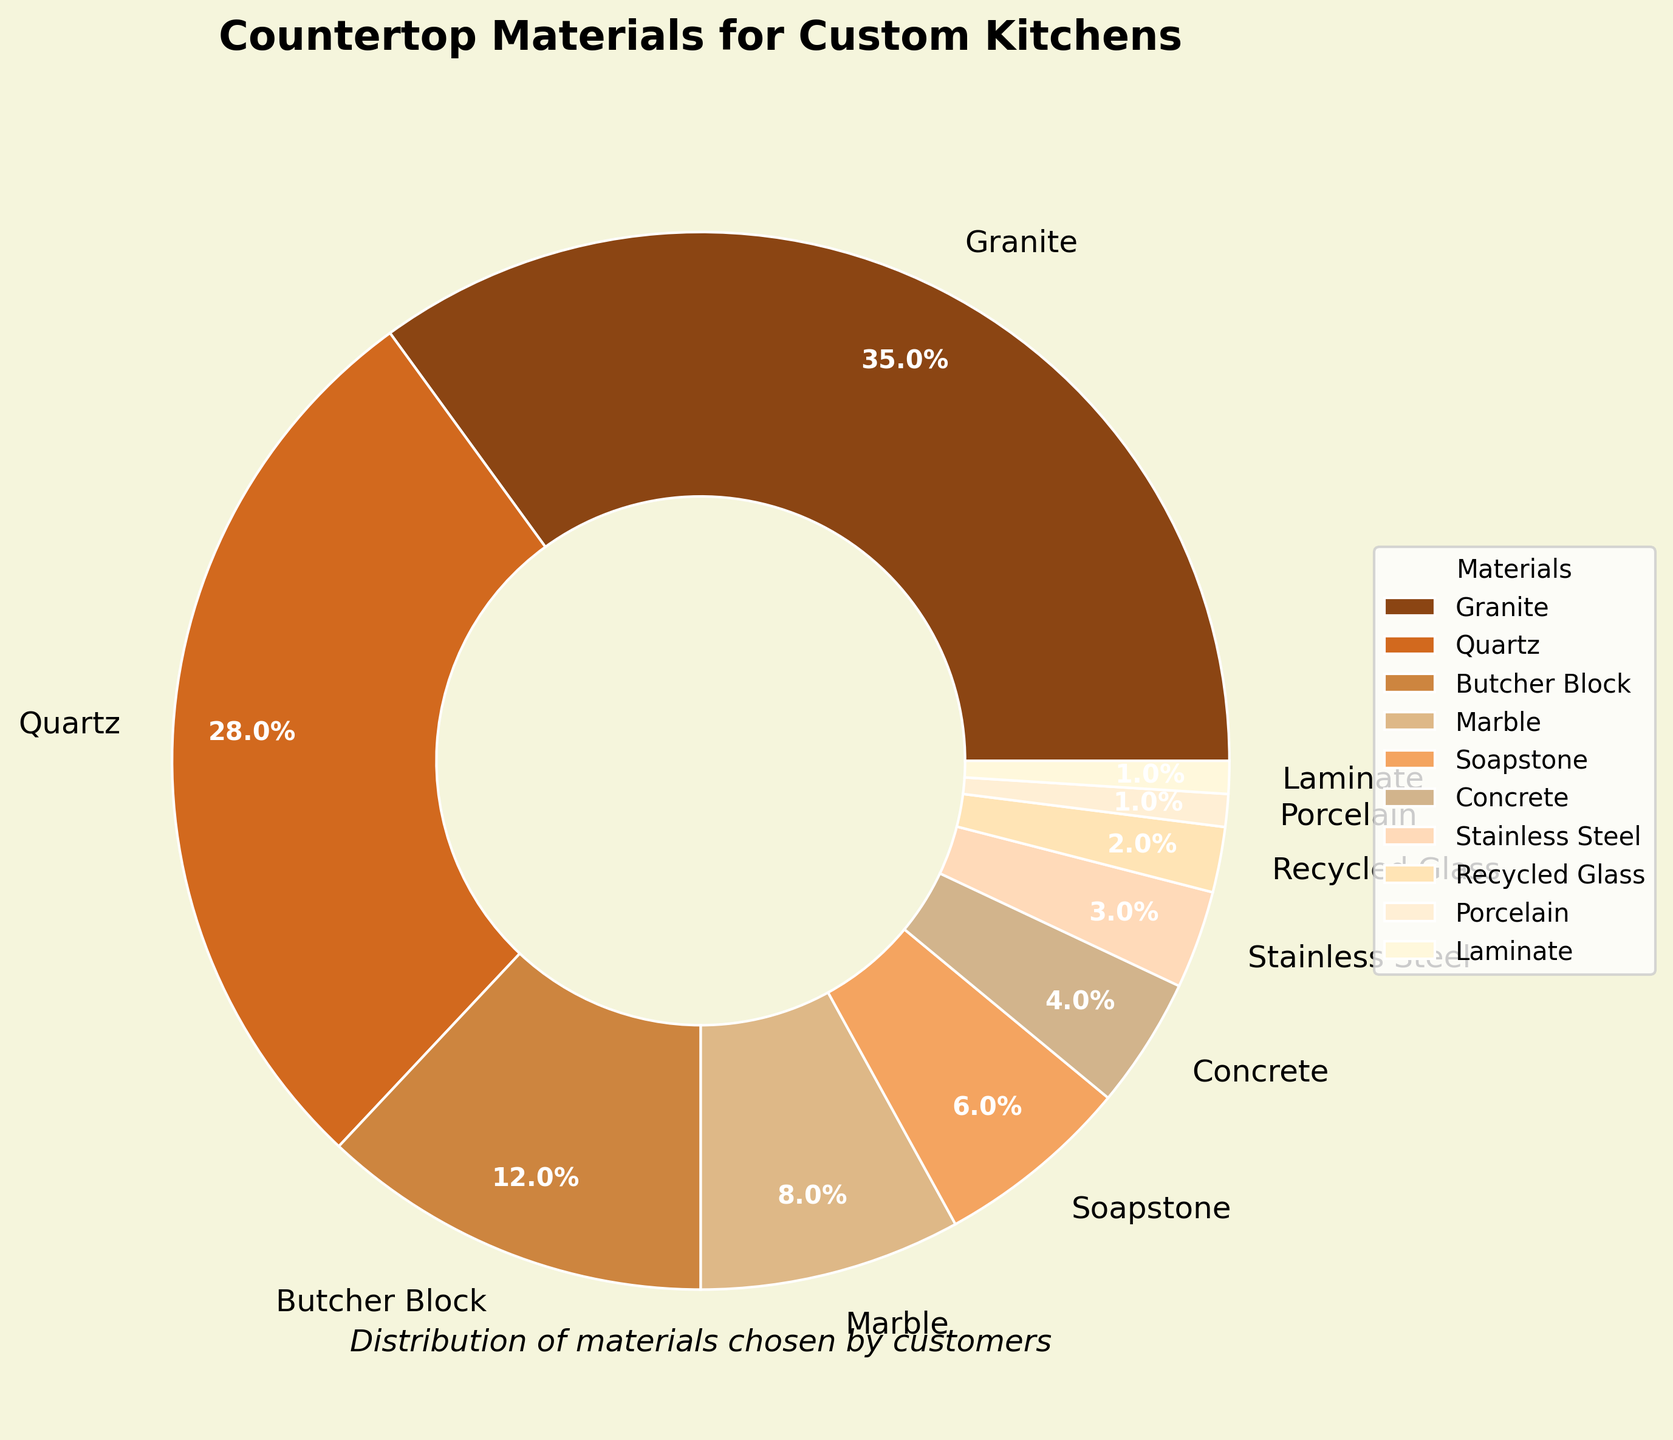What countertop material holds the biggest share in the chart? The figure shows the percentage of different materials chosen. Granite has the largest wedge at 35%, which makes it the biggest share.
Answer: Granite Which material is least preferred by customers according to the figure? The smallest wedge corresponds to Porcelain and Laminate, each with 1%.
Answer: Porcelain and Laminate What is the combined percentage for Quartz and Granite? Quartz has 28% and Granite has 35%. Adding them together, 28% + 35% = 63%.
Answer: 63% How does the percentage of Marble compare with Soapstone? The figure shows Marble has 8% and Soapstone has 6%. 8% is greater than 6%.
Answer: Marble is greater than Soapstone What is the difference in percentage between the most and least preferred materials? The most preferred material is Granite at 35%, and the least preferred materials are Porcelain and Laminate at 1%. The difference is 35% - 1% = 34%.
Answer: 34% What percentage of customers chose materials other than Granite? Granite is chosen by 35%, so the percentage not choosing Granite is 100% - 35% = 65%.
Answer: 65% Which materials have a wedge color closest to that of Quartz? Quartz has a distinctive orange-brown shade. Butcher Block and Soapstone have similar warm shades, though not exactly the same.
Answer: Butcher Block and Soapstone If you sum up the percentages of Marble, Soapstone, and Concrete, what total do you get? Marble is 8%, Soapstone is 6%, and Concrete is 4%. Summing these, 8% + 6% + 4% = 18%.
Answer: 18% Is the percentage of Butcher Block more or less than half the percentage of Granite? Butcher Block has a percentage of 12%, and half of Granite's 35% is 17.5%. Since 12% is less than 17.5%, Butcher Block is less than half of Granite's percentage.
Answer: Less What is the ratio of the percentage of Stainless Steel to the percentage of Recycled Glass? Stainless Steel is 3%, and Recycled Glass is 2%. The ratio is 3:2.
Answer: 3:2 